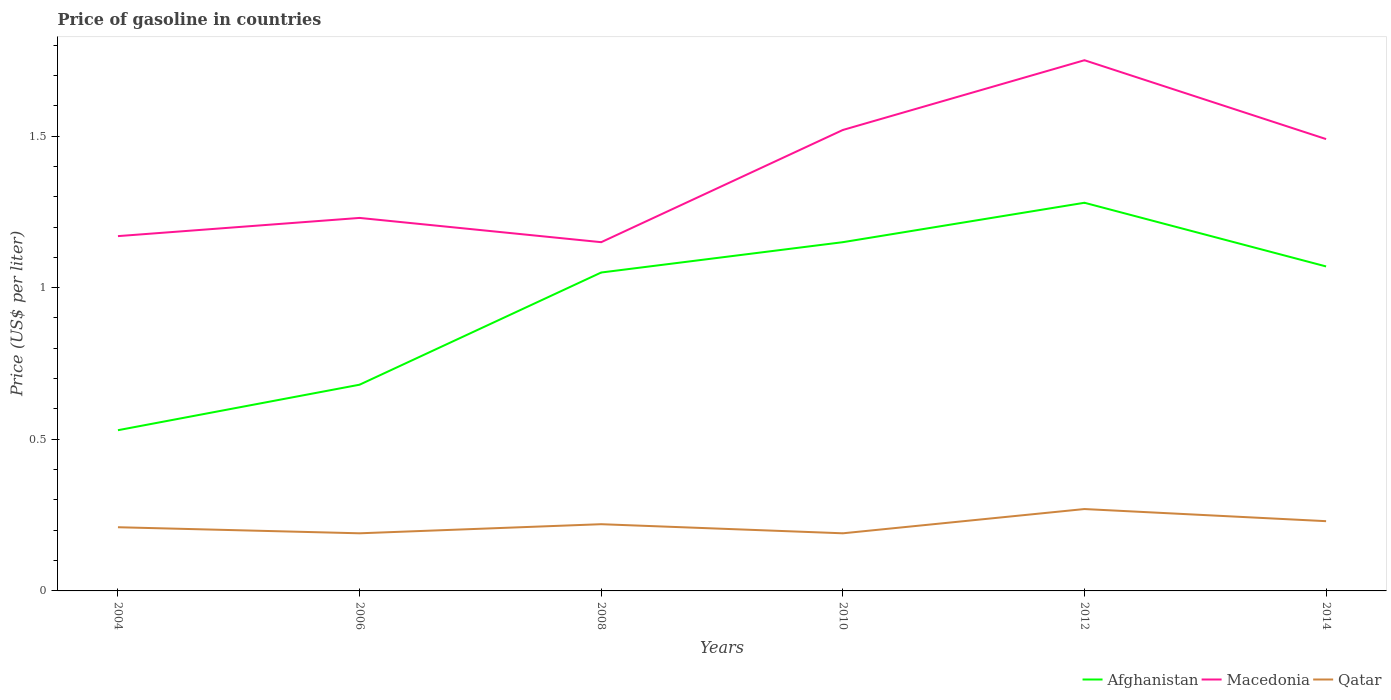Does the line corresponding to Qatar intersect with the line corresponding to Afghanistan?
Your response must be concise. No. Is the number of lines equal to the number of legend labels?
Keep it short and to the point. Yes. Across all years, what is the maximum price of gasoline in Qatar?
Make the answer very short. 0.19. In which year was the price of gasoline in Qatar maximum?
Offer a terse response. 2006. What is the total price of gasoline in Afghanistan in the graph?
Keep it short and to the point. -0.62. What is the difference between the highest and the second highest price of gasoline in Macedonia?
Your answer should be very brief. 0.6. Is the price of gasoline in Afghanistan strictly greater than the price of gasoline in Macedonia over the years?
Keep it short and to the point. Yes. How many lines are there?
Your answer should be very brief. 3. How many years are there in the graph?
Ensure brevity in your answer.  6. What is the difference between two consecutive major ticks on the Y-axis?
Your answer should be very brief. 0.5. Are the values on the major ticks of Y-axis written in scientific E-notation?
Make the answer very short. No. Where does the legend appear in the graph?
Your answer should be compact. Bottom right. How many legend labels are there?
Ensure brevity in your answer.  3. What is the title of the graph?
Offer a terse response. Price of gasoline in countries. What is the label or title of the Y-axis?
Provide a succinct answer. Price (US$ per liter). What is the Price (US$ per liter) in Afghanistan in 2004?
Offer a very short reply. 0.53. What is the Price (US$ per liter) in Macedonia in 2004?
Your answer should be compact. 1.17. What is the Price (US$ per liter) in Qatar in 2004?
Ensure brevity in your answer.  0.21. What is the Price (US$ per liter) in Afghanistan in 2006?
Provide a short and direct response. 0.68. What is the Price (US$ per liter) of Macedonia in 2006?
Offer a very short reply. 1.23. What is the Price (US$ per liter) of Qatar in 2006?
Provide a short and direct response. 0.19. What is the Price (US$ per liter) in Macedonia in 2008?
Your response must be concise. 1.15. What is the Price (US$ per liter) of Qatar in 2008?
Provide a short and direct response. 0.22. What is the Price (US$ per liter) in Afghanistan in 2010?
Provide a succinct answer. 1.15. What is the Price (US$ per liter) of Macedonia in 2010?
Offer a very short reply. 1.52. What is the Price (US$ per liter) of Qatar in 2010?
Give a very brief answer. 0.19. What is the Price (US$ per liter) in Afghanistan in 2012?
Your response must be concise. 1.28. What is the Price (US$ per liter) of Qatar in 2012?
Provide a short and direct response. 0.27. What is the Price (US$ per liter) of Afghanistan in 2014?
Ensure brevity in your answer.  1.07. What is the Price (US$ per liter) of Macedonia in 2014?
Provide a succinct answer. 1.49. What is the Price (US$ per liter) in Qatar in 2014?
Your response must be concise. 0.23. Across all years, what is the maximum Price (US$ per liter) of Afghanistan?
Ensure brevity in your answer.  1.28. Across all years, what is the maximum Price (US$ per liter) in Macedonia?
Your answer should be compact. 1.75. Across all years, what is the maximum Price (US$ per liter) in Qatar?
Provide a succinct answer. 0.27. Across all years, what is the minimum Price (US$ per liter) in Afghanistan?
Provide a short and direct response. 0.53. Across all years, what is the minimum Price (US$ per liter) of Macedonia?
Offer a very short reply. 1.15. Across all years, what is the minimum Price (US$ per liter) of Qatar?
Keep it short and to the point. 0.19. What is the total Price (US$ per liter) of Afghanistan in the graph?
Give a very brief answer. 5.76. What is the total Price (US$ per liter) of Macedonia in the graph?
Provide a succinct answer. 8.31. What is the total Price (US$ per liter) in Qatar in the graph?
Your answer should be compact. 1.31. What is the difference between the Price (US$ per liter) of Macedonia in 2004 and that in 2006?
Provide a short and direct response. -0.06. What is the difference between the Price (US$ per liter) of Qatar in 2004 and that in 2006?
Provide a short and direct response. 0.02. What is the difference between the Price (US$ per liter) of Afghanistan in 2004 and that in 2008?
Make the answer very short. -0.52. What is the difference between the Price (US$ per liter) in Qatar in 2004 and that in 2008?
Make the answer very short. -0.01. What is the difference between the Price (US$ per liter) in Afghanistan in 2004 and that in 2010?
Make the answer very short. -0.62. What is the difference between the Price (US$ per liter) in Macedonia in 2004 and that in 2010?
Your answer should be very brief. -0.35. What is the difference between the Price (US$ per liter) of Afghanistan in 2004 and that in 2012?
Your answer should be compact. -0.75. What is the difference between the Price (US$ per liter) in Macedonia in 2004 and that in 2012?
Offer a very short reply. -0.58. What is the difference between the Price (US$ per liter) in Qatar in 2004 and that in 2012?
Give a very brief answer. -0.06. What is the difference between the Price (US$ per liter) of Afghanistan in 2004 and that in 2014?
Your response must be concise. -0.54. What is the difference between the Price (US$ per liter) of Macedonia in 2004 and that in 2014?
Your response must be concise. -0.32. What is the difference between the Price (US$ per liter) of Qatar in 2004 and that in 2014?
Your response must be concise. -0.02. What is the difference between the Price (US$ per liter) of Afghanistan in 2006 and that in 2008?
Your response must be concise. -0.37. What is the difference between the Price (US$ per liter) of Qatar in 2006 and that in 2008?
Make the answer very short. -0.03. What is the difference between the Price (US$ per liter) in Afghanistan in 2006 and that in 2010?
Make the answer very short. -0.47. What is the difference between the Price (US$ per liter) in Macedonia in 2006 and that in 2010?
Provide a succinct answer. -0.29. What is the difference between the Price (US$ per liter) of Qatar in 2006 and that in 2010?
Make the answer very short. 0. What is the difference between the Price (US$ per liter) of Macedonia in 2006 and that in 2012?
Provide a succinct answer. -0.52. What is the difference between the Price (US$ per liter) in Qatar in 2006 and that in 2012?
Make the answer very short. -0.08. What is the difference between the Price (US$ per liter) in Afghanistan in 2006 and that in 2014?
Provide a short and direct response. -0.39. What is the difference between the Price (US$ per liter) of Macedonia in 2006 and that in 2014?
Ensure brevity in your answer.  -0.26. What is the difference between the Price (US$ per liter) of Qatar in 2006 and that in 2014?
Provide a succinct answer. -0.04. What is the difference between the Price (US$ per liter) of Afghanistan in 2008 and that in 2010?
Keep it short and to the point. -0.1. What is the difference between the Price (US$ per liter) of Macedonia in 2008 and that in 2010?
Your response must be concise. -0.37. What is the difference between the Price (US$ per liter) in Qatar in 2008 and that in 2010?
Keep it short and to the point. 0.03. What is the difference between the Price (US$ per liter) in Afghanistan in 2008 and that in 2012?
Provide a short and direct response. -0.23. What is the difference between the Price (US$ per liter) of Macedonia in 2008 and that in 2012?
Your answer should be very brief. -0.6. What is the difference between the Price (US$ per liter) in Qatar in 2008 and that in 2012?
Ensure brevity in your answer.  -0.05. What is the difference between the Price (US$ per liter) of Afghanistan in 2008 and that in 2014?
Offer a terse response. -0.02. What is the difference between the Price (US$ per liter) of Macedonia in 2008 and that in 2014?
Ensure brevity in your answer.  -0.34. What is the difference between the Price (US$ per liter) of Qatar in 2008 and that in 2014?
Offer a terse response. -0.01. What is the difference between the Price (US$ per liter) of Afghanistan in 2010 and that in 2012?
Your answer should be very brief. -0.13. What is the difference between the Price (US$ per liter) in Macedonia in 2010 and that in 2012?
Offer a terse response. -0.23. What is the difference between the Price (US$ per liter) of Qatar in 2010 and that in 2012?
Keep it short and to the point. -0.08. What is the difference between the Price (US$ per liter) in Afghanistan in 2010 and that in 2014?
Your answer should be compact. 0.08. What is the difference between the Price (US$ per liter) of Macedonia in 2010 and that in 2014?
Your response must be concise. 0.03. What is the difference between the Price (US$ per liter) of Qatar in 2010 and that in 2014?
Provide a short and direct response. -0.04. What is the difference between the Price (US$ per liter) in Afghanistan in 2012 and that in 2014?
Offer a terse response. 0.21. What is the difference between the Price (US$ per liter) in Macedonia in 2012 and that in 2014?
Your response must be concise. 0.26. What is the difference between the Price (US$ per liter) in Qatar in 2012 and that in 2014?
Provide a succinct answer. 0.04. What is the difference between the Price (US$ per liter) of Afghanistan in 2004 and the Price (US$ per liter) of Macedonia in 2006?
Keep it short and to the point. -0.7. What is the difference between the Price (US$ per liter) in Afghanistan in 2004 and the Price (US$ per liter) in Qatar in 2006?
Make the answer very short. 0.34. What is the difference between the Price (US$ per liter) in Afghanistan in 2004 and the Price (US$ per liter) in Macedonia in 2008?
Make the answer very short. -0.62. What is the difference between the Price (US$ per liter) of Afghanistan in 2004 and the Price (US$ per liter) of Qatar in 2008?
Make the answer very short. 0.31. What is the difference between the Price (US$ per liter) of Macedonia in 2004 and the Price (US$ per liter) of Qatar in 2008?
Give a very brief answer. 0.95. What is the difference between the Price (US$ per liter) of Afghanistan in 2004 and the Price (US$ per liter) of Macedonia in 2010?
Your response must be concise. -0.99. What is the difference between the Price (US$ per liter) of Afghanistan in 2004 and the Price (US$ per liter) of Qatar in 2010?
Keep it short and to the point. 0.34. What is the difference between the Price (US$ per liter) of Afghanistan in 2004 and the Price (US$ per liter) of Macedonia in 2012?
Offer a terse response. -1.22. What is the difference between the Price (US$ per liter) in Afghanistan in 2004 and the Price (US$ per liter) in Qatar in 2012?
Keep it short and to the point. 0.26. What is the difference between the Price (US$ per liter) of Afghanistan in 2004 and the Price (US$ per liter) of Macedonia in 2014?
Keep it short and to the point. -0.96. What is the difference between the Price (US$ per liter) of Macedonia in 2004 and the Price (US$ per liter) of Qatar in 2014?
Provide a succinct answer. 0.94. What is the difference between the Price (US$ per liter) of Afghanistan in 2006 and the Price (US$ per liter) of Macedonia in 2008?
Offer a terse response. -0.47. What is the difference between the Price (US$ per liter) in Afghanistan in 2006 and the Price (US$ per liter) in Qatar in 2008?
Provide a short and direct response. 0.46. What is the difference between the Price (US$ per liter) of Macedonia in 2006 and the Price (US$ per liter) of Qatar in 2008?
Make the answer very short. 1.01. What is the difference between the Price (US$ per liter) of Afghanistan in 2006 and the Price (US$ per liter) of Macedonia in 2010?
Provide a short and direct response. -0.84. What is the difference between the Price (US$ per liter) in Afghanistan in 2006 and the Price (US$ per liter) in Qatar in 2010?
Provide a short and direct response. 0.49. What is the difference between the Price (US$ per liter) in Afghanistan in 2006 and the Price (US$ per liter) in Macedonia in 2012?
Your answer should be compact. -1.07. What is the difference between the Price (US$ per liter) in Afghanistan in 2006 and the Price (US$ per liter) in Qatar in 2012?
Ensure brevity in your answer.  0.41. What is the difference between the Price (US$ per liter) in Afghanistan in 2006 and the Price (US$ per liter) in Macedonia in 2014?
Provide a succinct answer. -0.81. What is the difference between the Price (US$ per liter) of Afghanistan in 2006 and the Price (US$ per liter) of Qatar in 2014?
Offer a terse response. 0.45. What is the difference between the Price (US$ per liter) in Macedonia in 2006 and the Price (US$ per liter) in Qatar in 2014?
Provide a succinct answer. 1. What is the difference between the Price (US$ per liter) of Afghanistan in 2008 and the Price (US$ per liter) of Macedonia in 2010?
Your response must be concise. -0.47. What is the difference between the Price (US$ per liter) of Afghanistan in 2008 and the Price (US$ per liter) of Qatar in 2010?
Give a very brief answer. 0.86. What is the difference between the Price (US$ per liter) in Afghanistan in 2008 and the Price (US$ per liter) in Macedonia in 2012?
Offer a terse response. -0.7. What is the difference between the Price (US$ per liter) in Afghanistan in 2008 and the Price (US$ per liter) in Qatar in 2012?
Offer a terse response. 0.78. What is the difference between the Price (US$ per liter) in Macedonia in 2008 and the Price (US$ per liter) in Qatar in 2012?
Your response must be concise. 0.88. What is the difference between the Price (US$ per liter) of Afghanistan in 2008 and the Price (US$ per liter) of Macedonia in 2014?
Provide a succinct answer. -0.44. What is the difference between the Price (US$ per liter) in Afghanistan in 2008 and the Price (US$ per liter) in Qatar in 2014?
Provide a succinct answer. 0.82. What is the difference between the Price (US$ per liter) of Macedonia in 2008 and the Price (US$ per liter) of Qatar in 2014?
Offer a terse response. 0.92. What is the difference between the Price (US$ per liter) in Afghanistan in 2010 and the Price (US$ per liter) in Macedonia in 2012?
Give a very brief answer. -0.6. What is the difference between the Price (US$ per liter) of Afghanistan in 2010 and the Price (US$ per liter) of Macedonia in 2014?
Keep it short and to the point. -0.34. What is the difference between the Price (US$ per liter) in Afghanistan in 2010 and the Price (US$ per liter) in Qatar in 2014?
Provide a succinct answer. 0.92. What is the difference between the Price (US$ per liter) of Macedonia in 2010 and the Price (US$ per liter) of Qatar in 2014?
Make the answer very short. 1.29. What is the difference between the Price (US$ per liter) of Afghanistan in 2012 and the Price (US$ per liter) of Macedonia in 2014?
Offer a very short reply. -0.21. What is the difference between the Price (US$ per liter) in Macedonia in 2012 and the Price (US$ per liter) in Qatar in 2014?
Make the answer very short. 1.52. What is the average Price (US$ per liter) in Afghanistan per year?
Provide a succinct answer. 0.96. What is the average Price (US$ per liter) in Macedonia per year?
Give a very brief answer. 1.39. What is the average Price (US$ per liter) of Qatar per year?
Offer a very short reply. 0.22. In the year 2004, what is the difference between the Price (US$ per liter) of Afghanistan and Price (US$ per liter) of Macedonia?
Ensure brevity in your answer.  -0.64. In the year 2004, what is the difference between the Price (US$ per liter) in Afghanistan and Price (US$ per liter) in Qatar?
Your response must be concise. 0.32. In the year 2006, what is the difference between the Price (US$ per liter) in Afghanistan and Price (US$ per liter) in Macedonia?
Offer a very short reply. -0.55. In the year 2006, what is the difference between the Price (US$ per liter) of Afghanistan and Price (US$ per liter) of Qatar?
Give a very brief answer. 0.49. In the year 2008, what is the difference between the Price (US$ per liter) in Afghanistan and Price (US$ per liter) in Qatar?
Your answer should be very brief. 0.83. In the year 2010, what is the difference between the Price (US$ per liter) in Afghanistan and Price (US$ per liter) in Macedonia?
Provide a short and direct response. -0.37. In the year 2010, what is the difference between the Price (US$ per liter) of Afghanistan and Price (US$ per liter) of Qatar?
Provide a short and direct response. 0.96. In the year 2010, what is the difference between the Price (US$ per liter) of Macedonia and Price (US$ per liter) of Qatar?
Your answer should be compact. 1.33. In the year 2012, what is the difference between the Price (US$ per liter) of Afghanistan and Price (US$ per liter) of Macedonia?
Ensure brevity in your answer.  -0.47. In the year 2012, what is the difference between the Price (US$ per liter) in Macedonia and Price (US$ per liter) in Qatar?
Provide a short and direct response. 1.48. In the year 2014, what is the difference between the Price (US$ per liter) of Afghanistan and Price (US$ per liter) of Macedonia?
Your answer should be compact. -0.42. In the year 2014, what is the difference between the Price (US$ per liter) of Afghanistan and Price (US$ per liter) of Qatar?
Your answer should be very brief. 0.84. In the year 2014, what is the difference between the Price (US$ per liter) of Macedonia and Price (US$ per liter) of Qatar?
Make the answer very short. 1.26. What is the ratio of the Price (US$ per liter) of Afghanistan in 2004 to that in 2006?
Your answer should be very brief. 0.78. What is the ratio of the Price (US$ per liter) in Macedonia in 2004 to that in 2006?
Provide a succinct answer. 0.95. What is the ratio of the Price (US$ per liter) of Qatar in 2004 to that in 2006?
Keep it short and to the point. 1.11. What is the ratio of the Price (US$ per liter) of Afghanistan in 2004 to that in 2008?
Give a very brief answer. 0.5. What is the ratio of the Price (US$ per liter) in Macedonia in 2004 to that in 2008?
Offer a very short reply. 1.02. What is the ratio of the Price (US$ per liter) in Qatar in 2004 to that in 2008?
Provide a succinct answer. 0.95. What is the ratio of the Price (US$ per liter) in Afghanistan in 2004 to that in 2010?
Provide a short and direct response. 0.46. What is the ratio of the Price (US$ per liter) in Macedonia in 2004 to that in 2010?
Your answer should be compact. 0.77. What is the ratio of the Price (US$ per liter) in Qatar in 2004 to that in 2010?
Keep it short and to the point. 1.11. What is the ratio of the Price (US$ per liter) in Afghanistan in 2004 to that in 2012?
Make the answer very short. 0.41. What is the ratio of the Price (US$ per liter) of Macedonia in 2004 to that in 2012?
Provide a succinct answer. 0.67. What is the ratio of the Price (US$ per liter) in Qatar in 2004 to that in 2012?
Keep it short and to the point. 0.78. What is the ratio of the Price (US$ per liter) in Afghanistan in 2004 to that in 2014?
Provide a succinct answer. 0.5. What is the ratio of the Price (US$ per liter) in Macedonia in 2004 to that in 2014?
Give a very brief answer. 0.79. What is the ratio of the Price (US$ per liter) in Qatar in 2004 to that in 2014?
Keep it short and to the point. 0.91. What is the ratio of the Price (US$ per liter) of Afghanistan in 2006 to that in 2008?
Keep it short and to the point. 0.65. What is the ratio of the Price (US$ per liter) in Macedonia in 2006 to that in 2008?
Your answer should be very brief. 1.07. What is the ratio of the Price (US$ per liter) of Qatar in 2006 to that in 2008?
Give a very brief answer. 0.86. What is the ratio of the Price (US$ per liter) of Afghanistan in 2006 to that in 2010?
Keep it short and to the point. 0.59. What is the ratio of the Price (US$ per liter) in Macedonia in 2006 to that in 2010?
Your answer should be compact. 0.81. What is the ratio of the Price (US$ per liter) in Afghanistan in 2006 to that in 2012?
Give a very brief answer. 0.53. What is the ratio of the Price (US$ per liter) in Macedonia in 2006 to that in 2012?
Offer a terse response. 0.7. What is the ratio of the Price (US$ per liter) of Qatar in 2006 to that in 2012?
Keep it short and to the point. 0.7. What is the ratio of the Price (US$ per liter) in Afghanistan in 2006 to that in 2014?
Offer a very short reply. 0.64. What is the ratio of the Price (US$ per liter) in Macedonia in 2006 to that in 2014?
Provide a short and direct response. 0.83. What is the ratio of the Price (US$ per liter) in Qatar in 2006 to that in 2014?
Your answer should be very brief. 0.83. What is the ratio of the Price (US$ per liter) of Afghanistan in 2008 to that in 2010?
Make the answer very short. 0.91. What is the ratio of the Price (US$ per liter) in Macedonia in 2008 to that in 2010?
Your answer should be compact. 0.76. What is the ratio of the Price (US$ per liter) in Qatar in 2008 to that in 2010?
Make the answer very short. 1.16. What is the ratio of the Price (US$ per liter) of Afghanistan in 2008 to that in 2012?
Provide a succinct answer. 0.82. What is the ratio of the Price (US$ per liter) in Macedonia in 2008 to that in 2012?
Keep it short and to the point. 0.66. What is the ratio of the Price (US$ per liter) in Qatar in 2008 to that in 2012?
Your response must be concise. 0.81. What is the ratio of the Price (US$ per liter) of Afghanistan in 2008 to that in 2014?
Offer a very short reply. 0.98. What is the ratio of the Price (US$ per liter) in Macedonia in 2008 to that in 2014?
Provide a short and direct response. 0.77. What is the ratio of the Price (US$ per liter) in Qatar in 2008 to that in 2014?
Keep it short and to the point. 0.96. What is the ratio of the Price (US$ per liter) of Afghanistan in 2010 to that in 2012?
Keep it short and to the point. 0.9. What is the ratio of the Price (US$ per liter) of Macedonia in 2010 to that in 2012?
Ensure brevity in your answer.  0.87. What is the ratio of the Price (US$ per liter) in Qatar in 2010 to that in 2012?
Offer a terse response. 0.7. What is the ratio of the Price (US$ per liter) in Afghanistan in 2010 to that in 2014?
Offer a very short reply. 1.07. What is the ratio of the Price (US$ per liter) of Macedonia in 2010 to that in 2014?
Offer a very short reply. 1.02. What is the ratio of the Price (US$ per liter) of Qatar in 2010 to that in 2014?
Your response must be concise. 0.83. What is the ratio of the Price (US$ per liter) in Afghanistan in 2012 to that in 2014?
Offer a terse response. 1.2. What is the ratio of the Price (US$ per liter) of Macedonia in 2012 to that in 2014?
Offer a very short reply. 1.17. What is the ratio of the Price (US$ per liter) in Qatar in 2012 to that in 2014?
Your response must be concise. 1.17. What is the difference between the highest and the second highest Price (US$ per liter) of Afghanistan?
Give a very brief answer. 0.13. What is the difference between the highest and the second highest Price (US$ per liter) of Macedonia?
Provide a succinct answer. 0.23. What is the difference between the highest and the lowest Price (US$ per liter) in Afghanistan?
Ensure brevity in your answer.  0.75. 